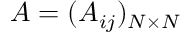Convert formula to latex. <formula><loc_0><loc_0><loc_500><loc_500>A = ( A _ { i j } ) _ { N \times N }</formula> 